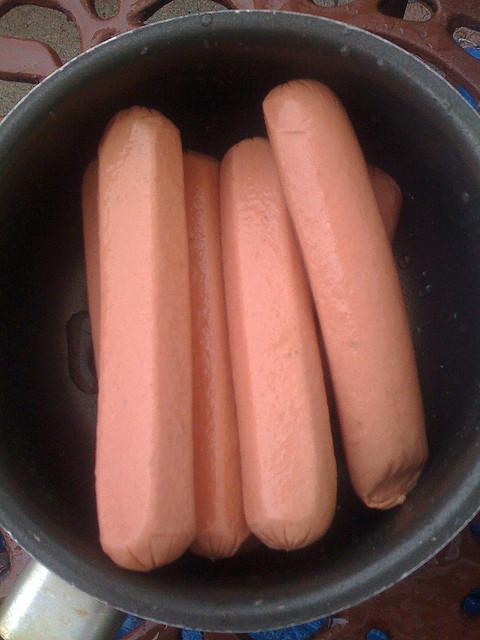What is bad about this food?

Choices:
A) high fat
B) high carb
C) high sugar
D) high sodium high sodium 